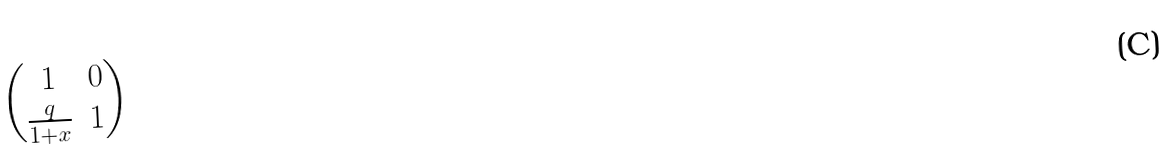<formula> <loc_0><loc_0><loc_500><loc_500>\begin{pmatrix} 1 & 0 \\ \frac { q } { 1 + x } & 1 \end{pmatrix}</formula> 